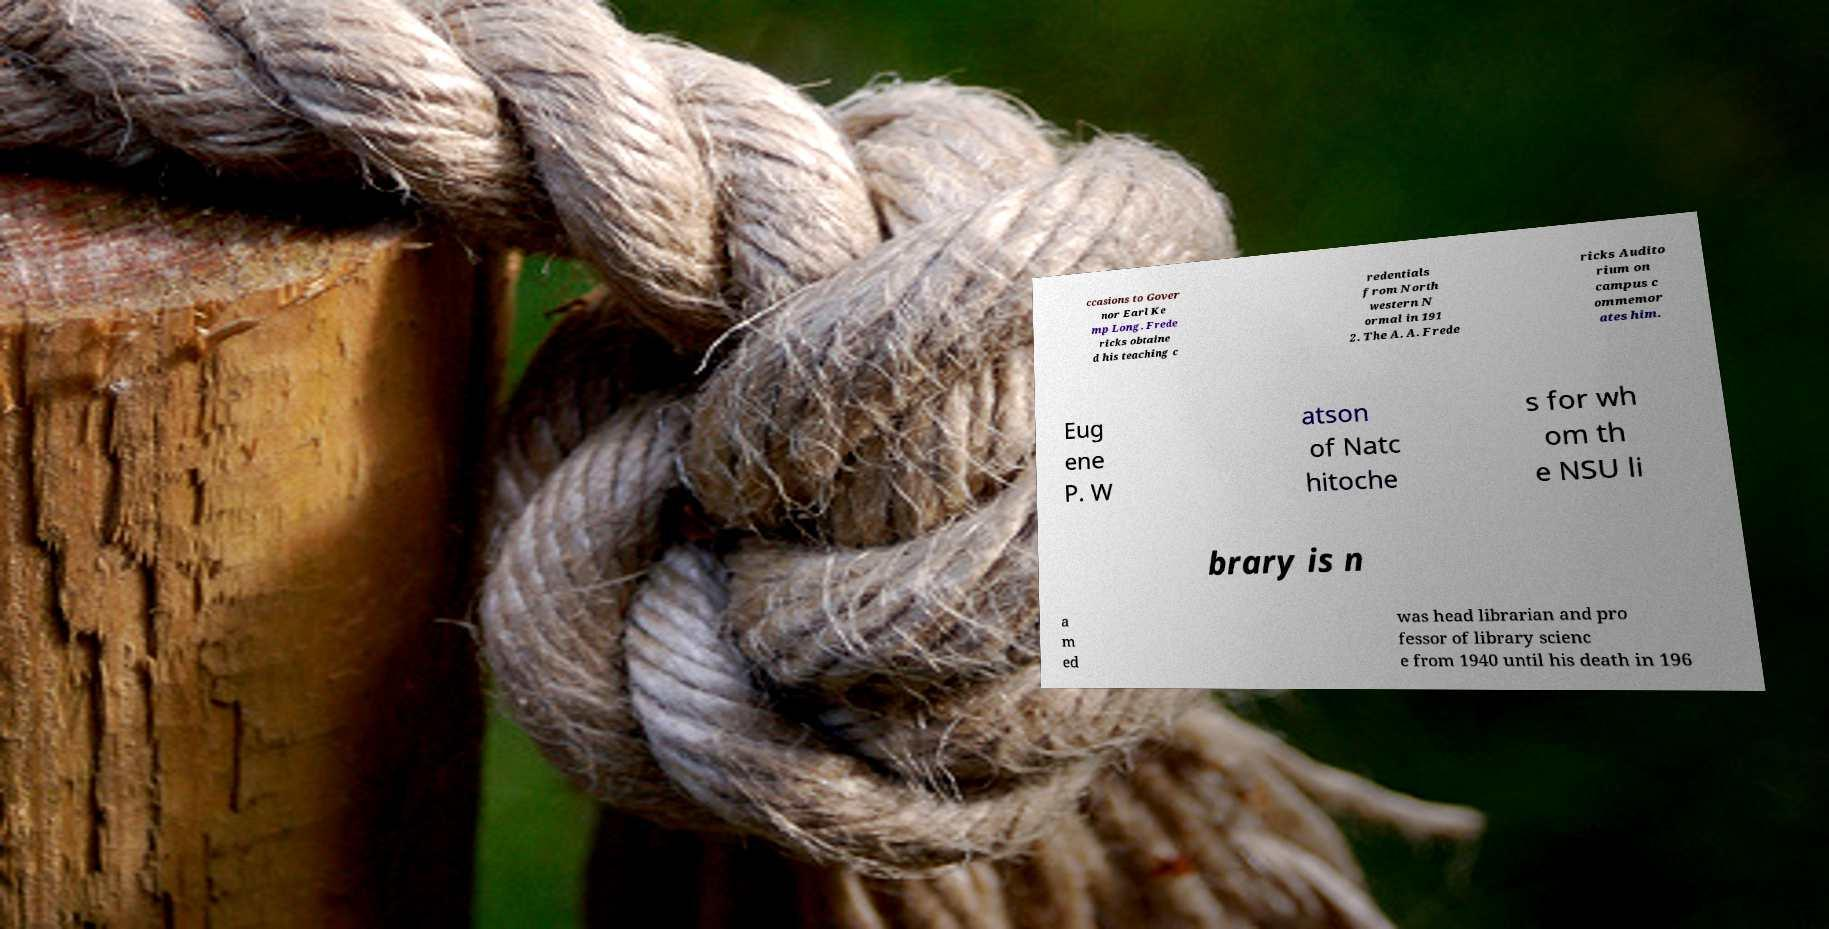What messages or text are displayed in this image? I need them in a readable, typed format. ccasions to Gover nor Earl Ke mp Long. Frede ricks obtaine d his teaching c redentials from North western N ormal in 191 2. The A. A. Frede ricks Audito rium on campus c ommemor ates him. Eug ene P. W atson of Natc hitoche s for wh om th e NSU li brary is n a m ed was head librarian and pro fessor of library scienc e from 1940 until his death in 196 